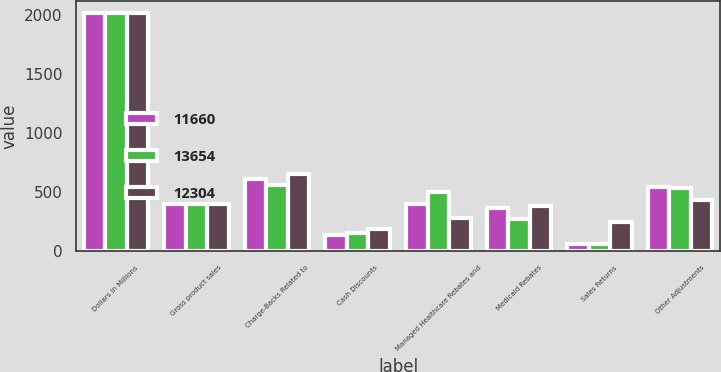Convert chart to OTSL. <chart><loc_0><loc_0><loc_500><loc_500><stacked_bar_chart><ecel><fcel>Dollars in Millions<fcel>Gross product sales<fcel>Charge-Backs Related to<fcel>Cash Discounts<fcel>Managed Healthcare Rebates and<fcel>Medicaid Rebates<fcel>Sales Returns<fcel>Other Adjustments<nl><fcel>11660<fcel>2014<fcel>399<fcel>614<fcel>141<fcel>399<fcel>370<fcel>61<fcel>548<nl><fcel>13654<fcel>2013<fcel>399<fcel>563<fcel>154<fcel>499<fcel>275<fcel>62<fcel>534<nl><fcel>12304<fcel>2012<fcel>399<fcel>651<fcel>192<fcel>284<fcel>386<fcel>248<fcel>434<nl></chart> 